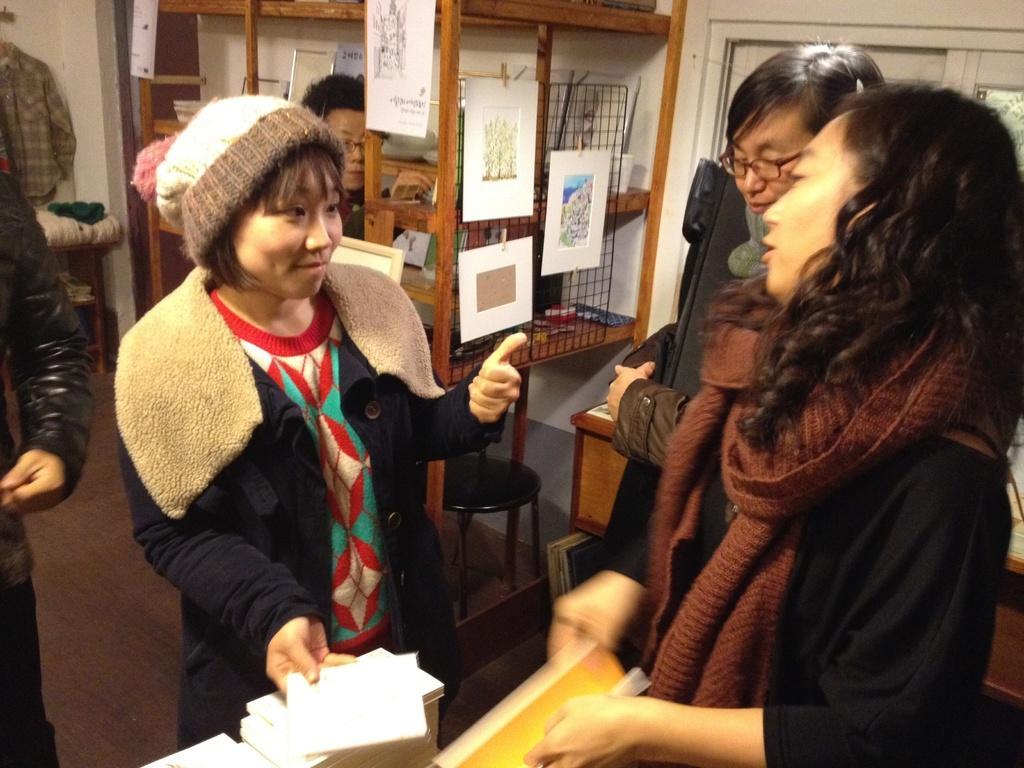How would you summarize this image in a sentence or two? In this picture I can see there are few people standing and there are two people standing at right and there is a woman standing at left and she is holding a paper. In the backdrop there is a man and there are few papers attached to the wall. 